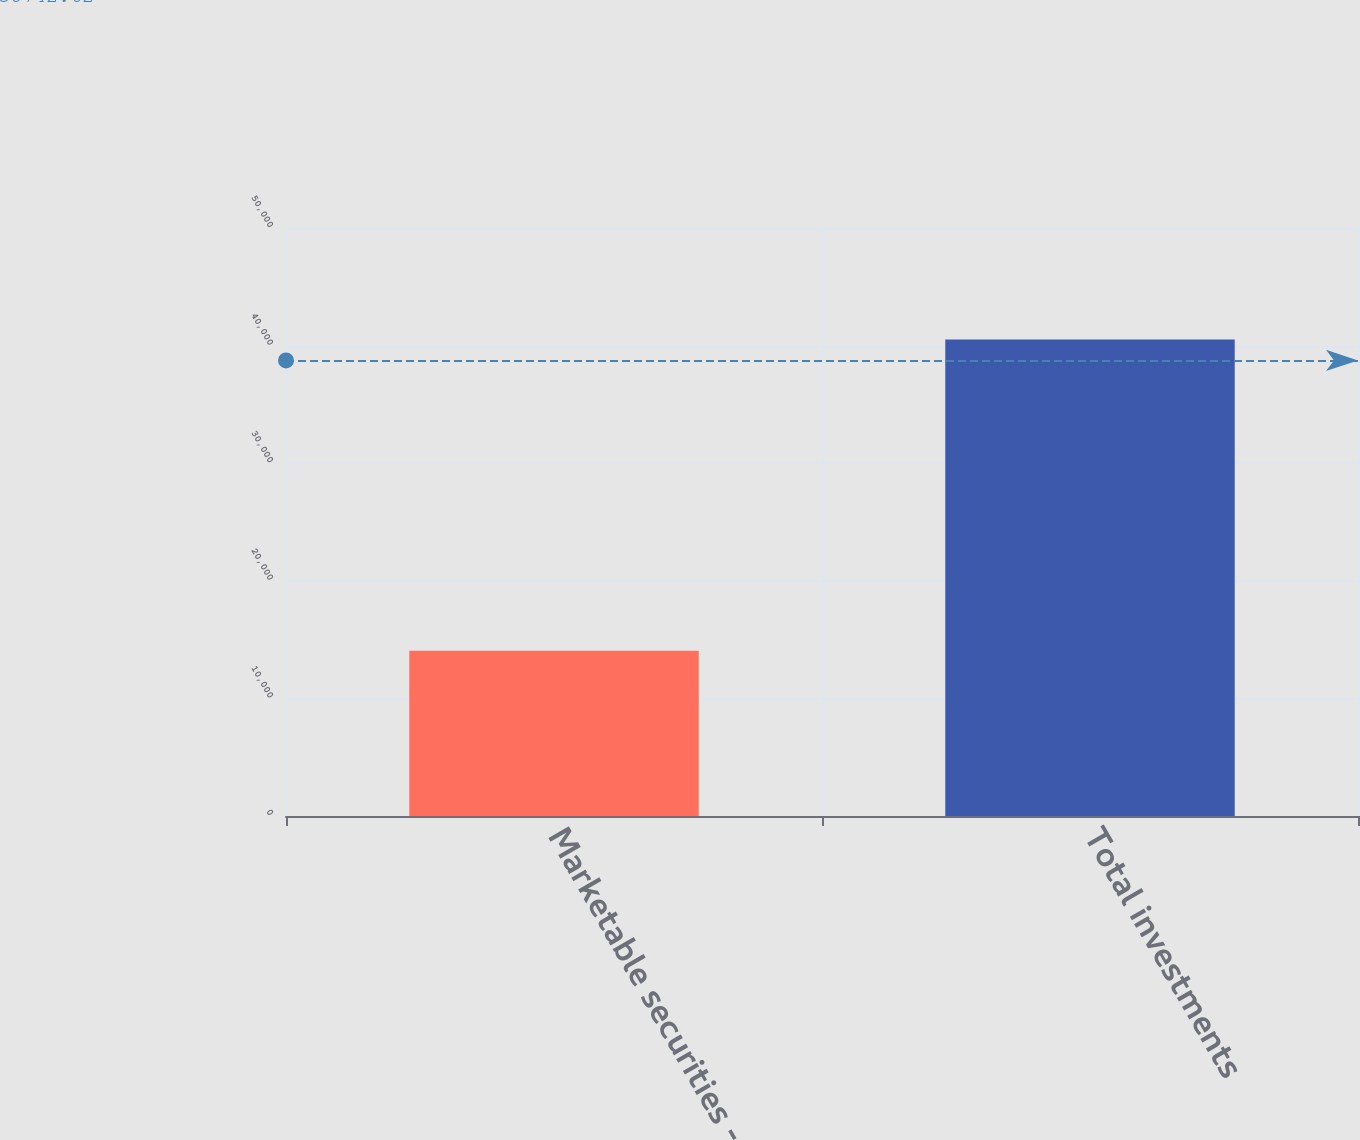<chart> <loc_0><loc_0><loc_500><loc_500><bar_chart><fcel>Marketable securities -<fcel>Total investments<nl><fcel>14044<fcel>40519<nl></chart> 